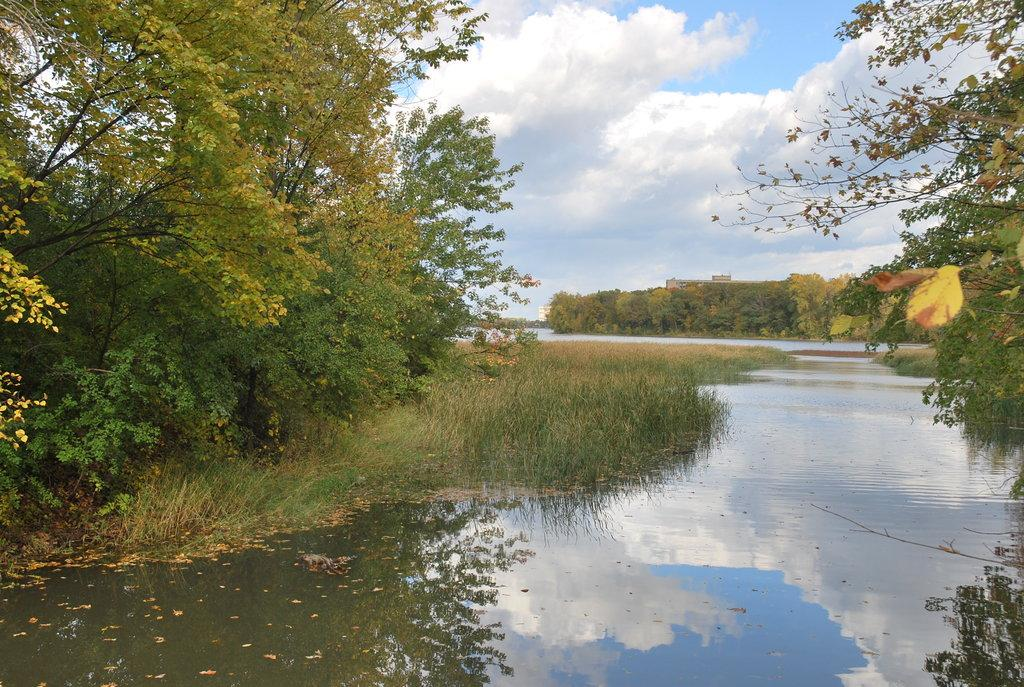What type of vegetation can be seen in the image? There are trees in the image. What is the ground covered with in the image? There is grass in the image. What natural element is visible in the image? There is water visible in the image. What type of structure is present in the image? There is a building in the image. How would you describe the sky in the image? The sky is cloudy in the image. How many passengers are visible in the image? There are no passengers present in the image. What type of noise can be heard coming from the rainstorm in the image? There is no rainstorm present in the image, so no such noise can be heard. 